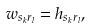<formula> <loc_0><loc_0><loc_500><loc_500>w _ { s _ { k } r _ { l } } = h _ { s _ { k } r _ { l } } ,</formula> 